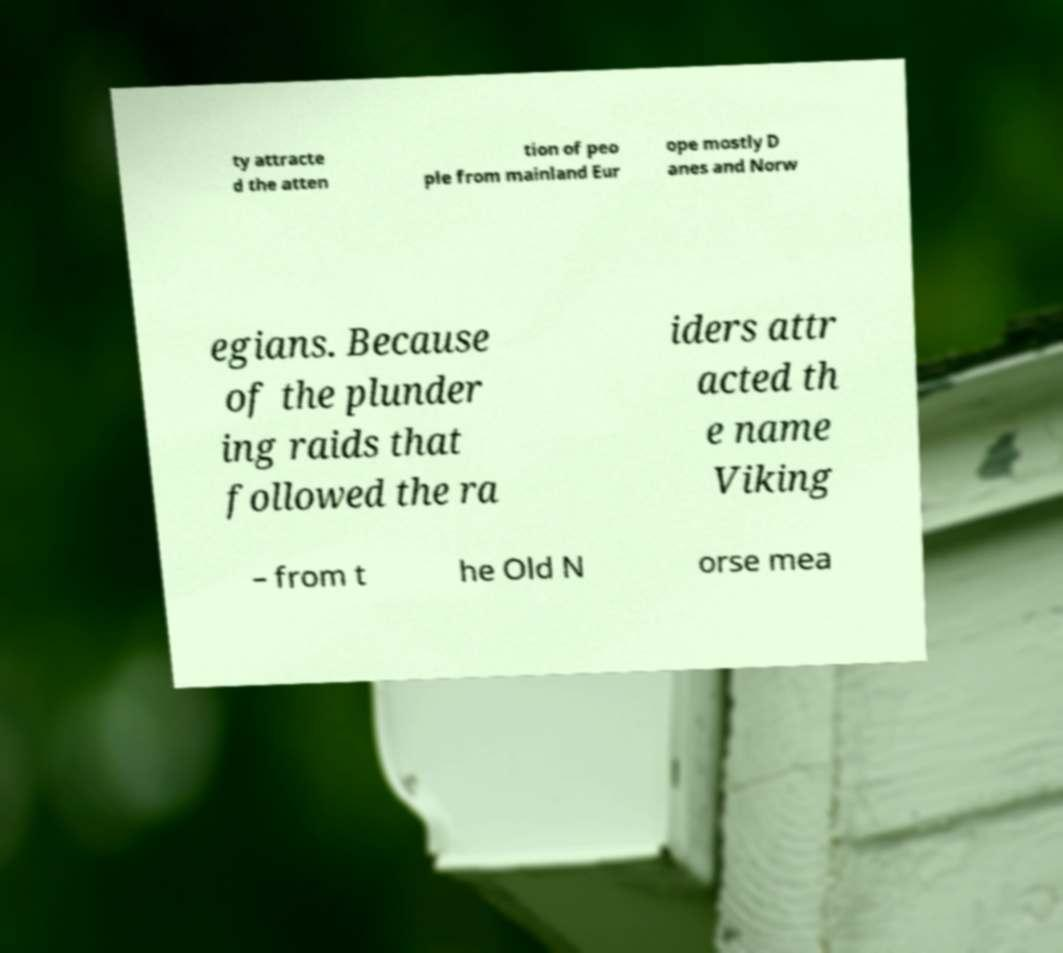Please identify and transcribe the text found in this image. ty attracte d the atten tion of peo ple from mainland Eur ope mostly D anes and Norw egians. Because of the plunder ing raids that followed the ra iders attr acted th e name Viking – from t he Old N orse mea 